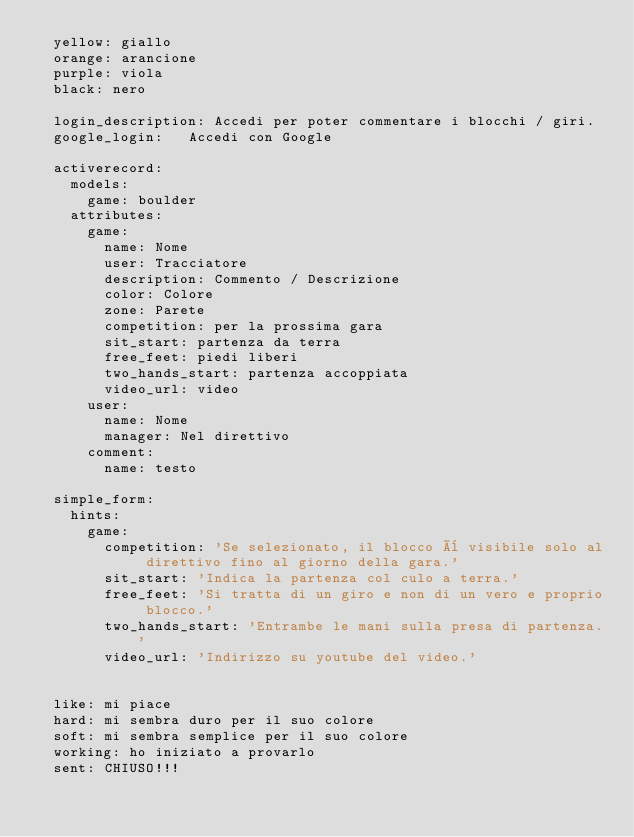<code> <loc_0><loc_0><loc_500><loc_500><_YAML_>  yellow: giallo
  orange: arancione
  purple: viola
  black: nero

  login_description: Accedi per poter commentare i blocchi / giri.
  google_login:   Accedi con Google

  activerecord:
    models:
      game: boulder
    attributes:
      game:
        name: Nome
        user: Tracciatore
        description: Commento / Descrizione
        color: Colore
        zone: Parete
        competition: per la prossima gara
        sit_start: partenza da terra
        free_feet: piedi liberi
        two_hands_start: partenza accoppiata     
        video_url: video
      user:
        name: Nome
        manager: Nel direttivo
      comment:
        name: testo

  simple_form:
    hints:
      game:
        competition: 'Se selezionato, il blocco è visibile solo al direttivo fino al giorno della gara.'
        sit_start: 'Indica la partenza col culo a terra.'
        free_feet: 'Si tratta di un giro e non di un vero e proprio blocco.'
        two_hands_start: 'Entrambe le mani sulla presa di partenza.'
        video_url: 'Indirizzo su youtube del video.'

  
  like: mi piace
  hard: mi sembra duro per il suo colore
  soft: mi sembra semplice per il suo colore
  working: ho iniziato a provarlo
  sent: CHIUSO!!!
</code> 